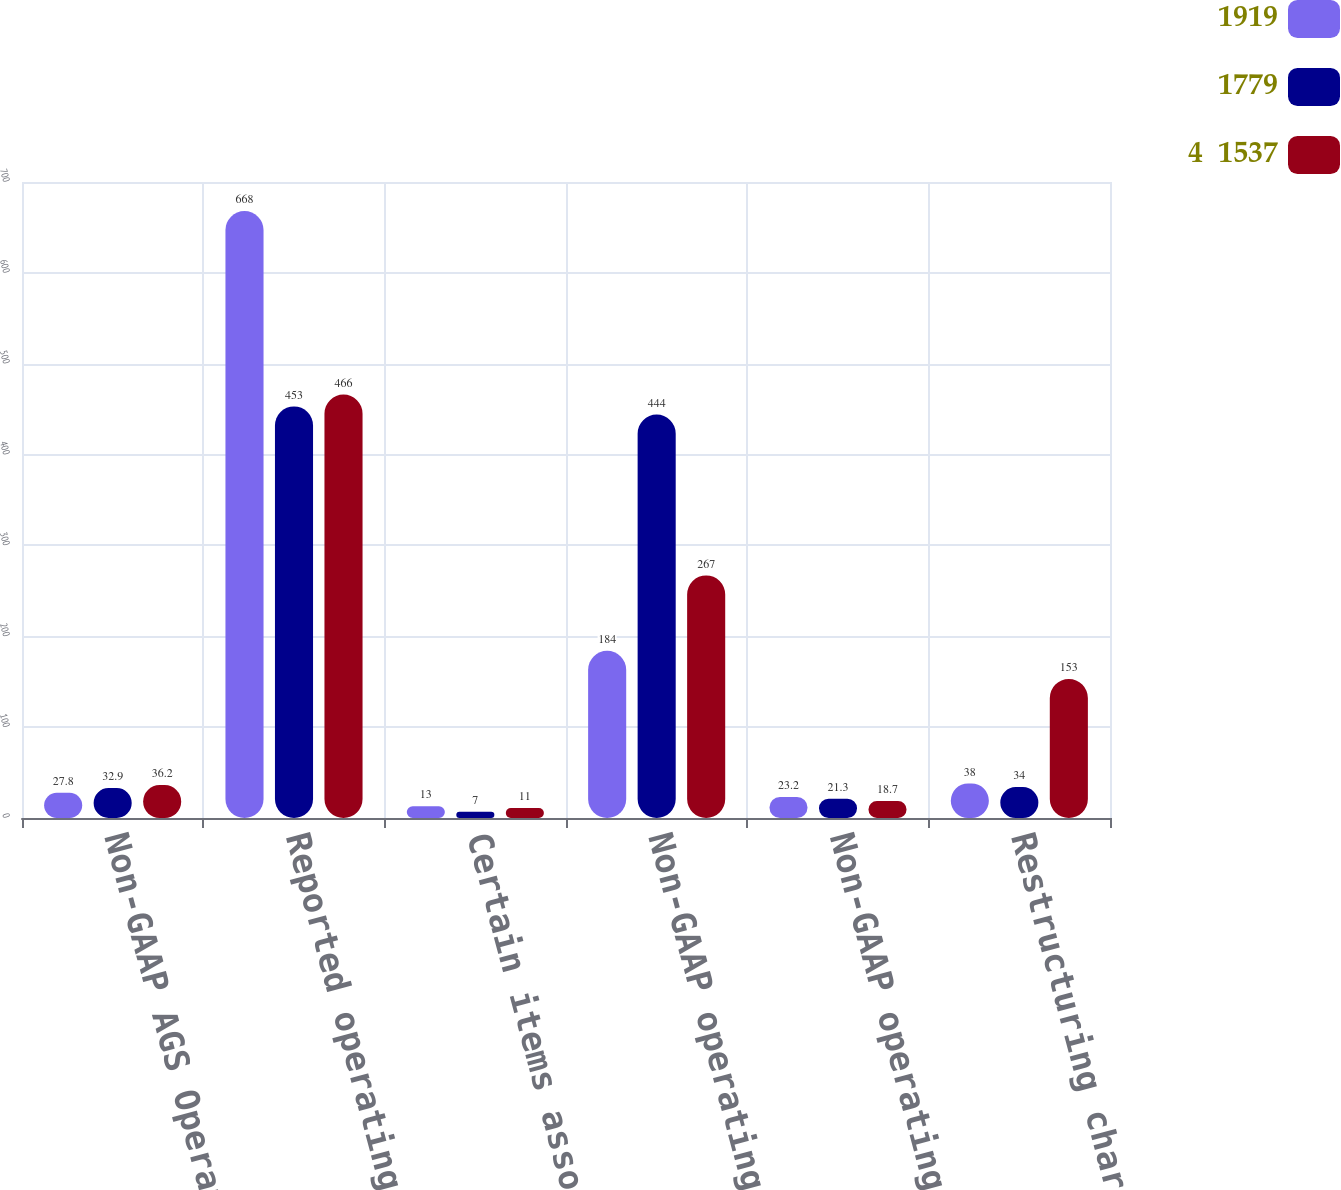Convert chart. <chart><loc_0><loc_0><loc_500><loc_500><stacked_bar_chart><ecel><fcel>Non-GAAP AGS Operating Income<fcel>Reported operating income<fcel>Certain items associated with<fcel>Non-GAAP operating income<fcel>Non-GAAP operating margin<fcel>Restructuring charges and<nl><fcel>1919<fcel>27.8<fcel>668<fcel>13<fcel>184<fcel>23.2<fcel>38<nl><fcel>1779<fcel>32.9<fcel>453<fcel>7<fcel>444<fcel>21.3<fcel>34<nl><fcel>4  1537<fcel>36.2<fcel>466<fcel>11<fcel>267<fcel>18.7<fcel>153<nl></chart> 